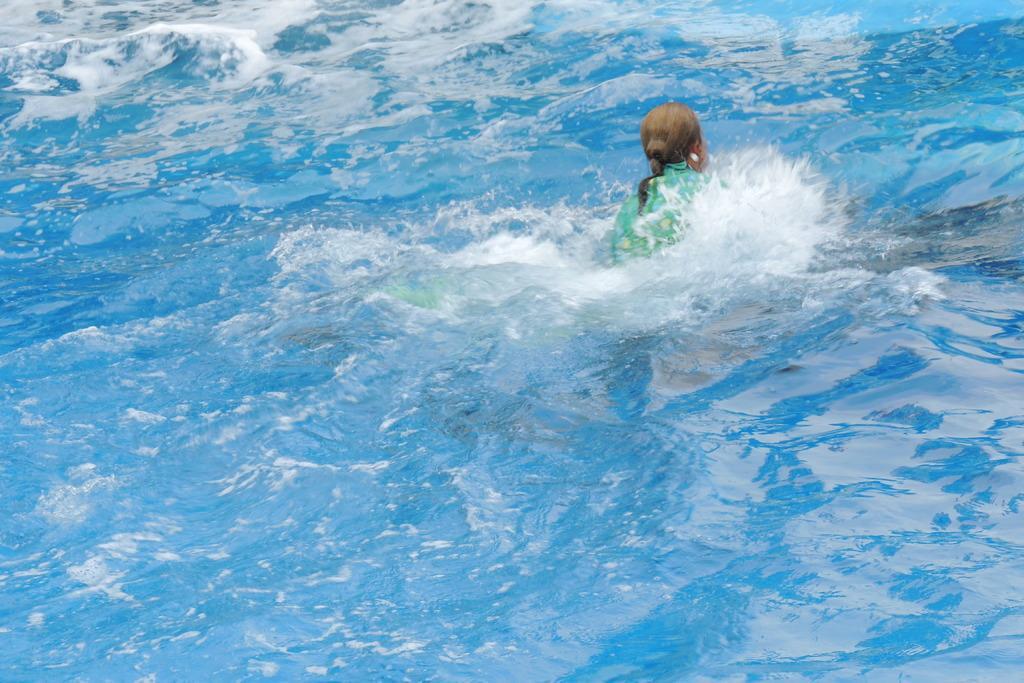Describe this image in one or two sentences. A person is in water. 